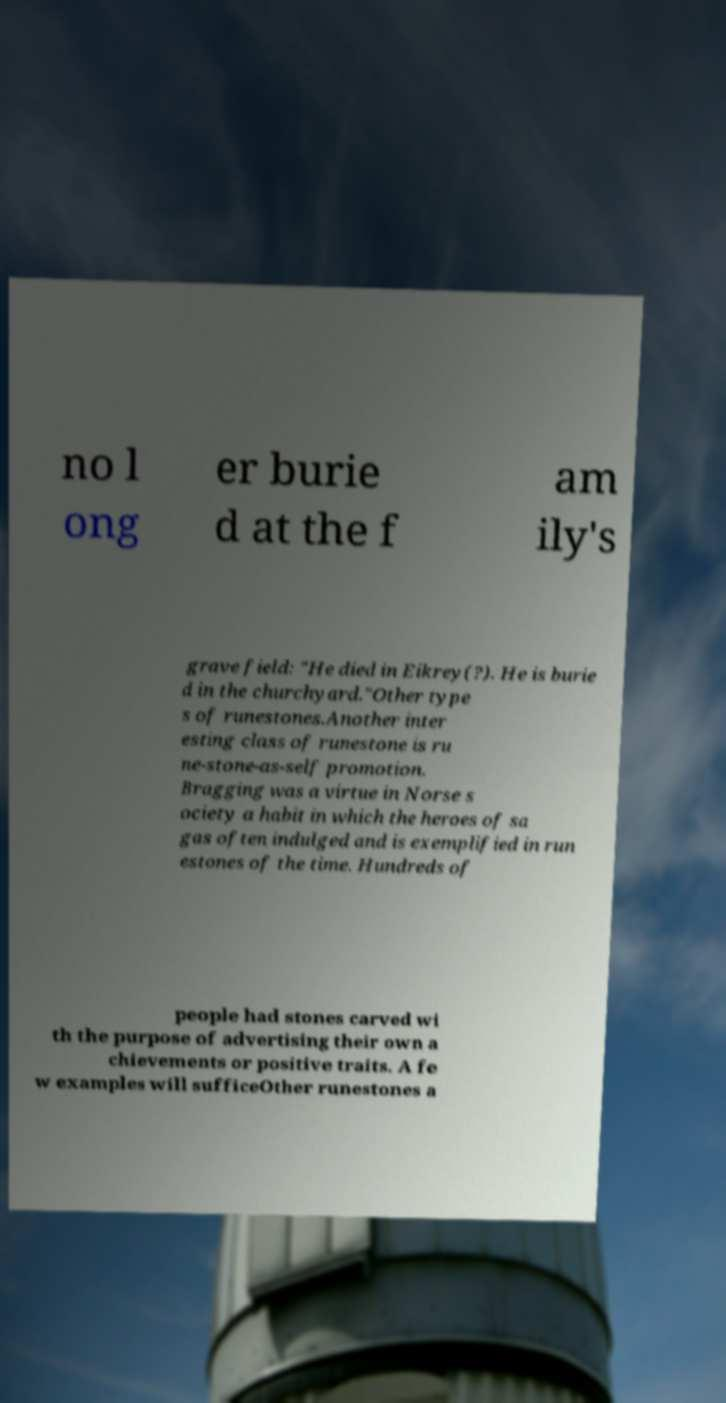I need the written content from this picture converted into text. Can you do that? no l ong er burie d at the f am ily's grave field: "He died in Eikrey(?). He is burie d in the churchyard."Other type s of runestones.Another inter esting class of runestone is ru ne-stone-as-self promotion. Bragging was a virtue in Norse s ociety a habit in which the heroes of sa gas often indulged and is exemplified in run estones of the time. Hundreds of people had stones carved wi th the purpose of advertising their own a chievements or positive traits. A fe w examples will sufficeOther runestones a 